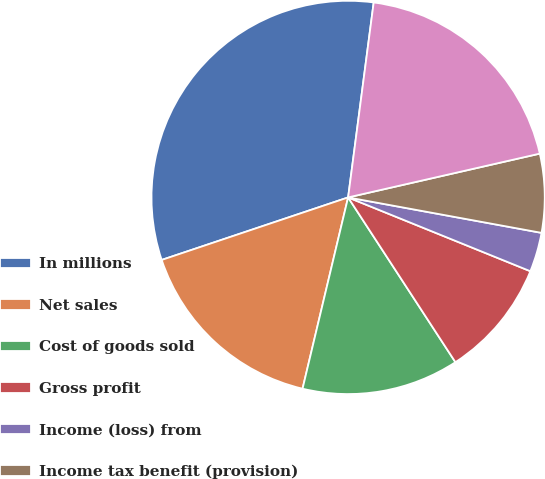<chart> <loc_0><loc_0><loc_500><loc_500><pie_chart><fcel>In millions<fcel>Net sales<fcel>Cost of goods sold<fcel>Gross profit<fcel>Income (loss) from<fcel>Income tax benefit (provision)<fcel>Loss from sale / impairment of<nl><fcel>32.23%<fcel>16.13%<fcel>12.91%<fcel>9.69%<fcel>3.24%<fcel>6.46%<fcel>19.35%<nl></chart> 